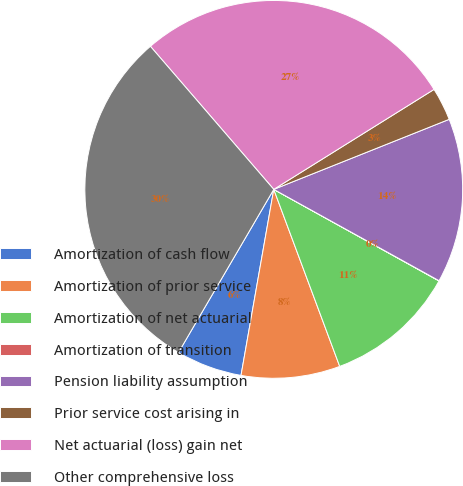Convert chart. <chart><loc_0><loc_0><loc_500><loc_500><pie_chart><fcel>Amortization of cash flow<fcel>Amortization of prior service<fcel>Amortization of net actuarial<fcel>Amortization of transition<fcel>Pension liability assumption<fcel>Prior service cost arising in<fcel>Net actuarial (loss) gain net<fcel>Other comprehensive loss<nl><fcel>5.64%<fcel>8.45%<fcel>11.27%<fcel>0.02%<fcel>14.08%<fcel>2.83%<fcel>27.45%<fcel>30.26%<nl></chart> 